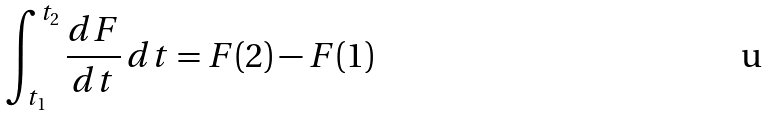Convert formula to latex. <formula><loc_0><loc_0><loc_500><loc_500>\int _ { t _ { 1 } } ^ { t _ { 2 } } \frac { d F } { d t } \, d t = F ( 2 ) - F ( 1 )</formula> 